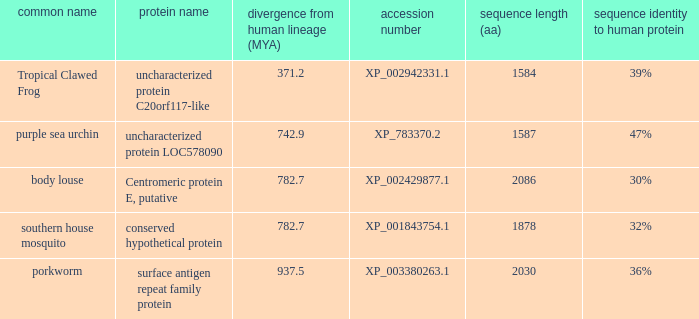What is the accession number of the protein with a divergence from human lineage of 937.5? XP_003380263.1. 